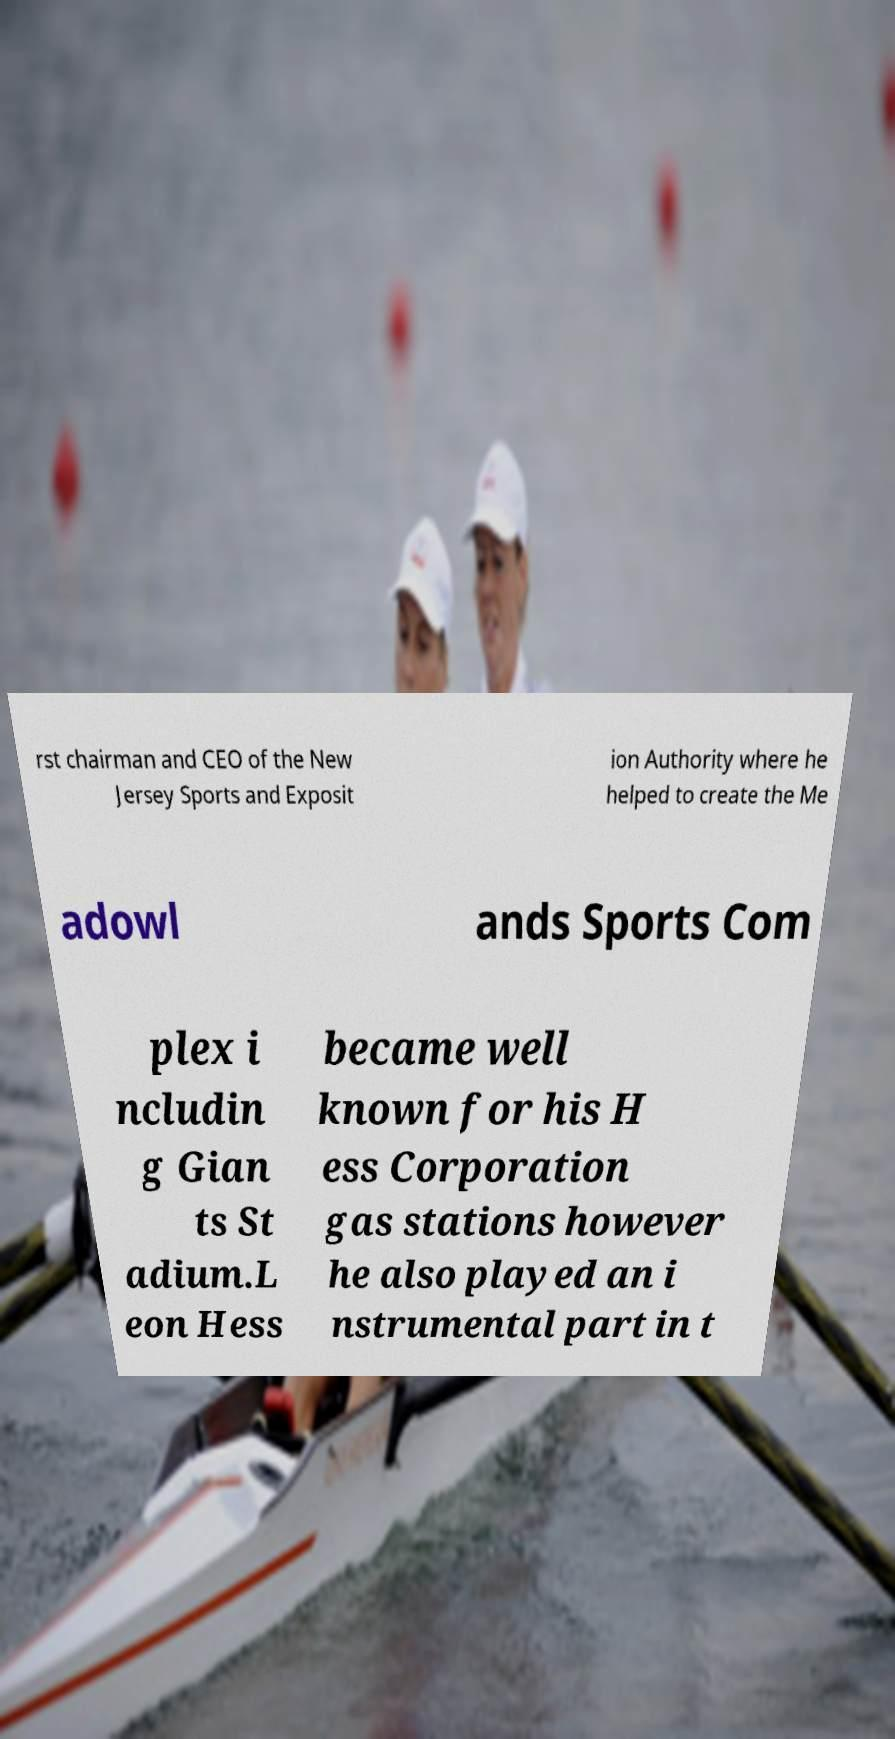Please identify and transcribe the text found in this image. rst chairman and CEO of the New Jersey Sports and Exposit ion Authority where he helped to create the Me adowl ands Sports Com plex i ncludin g Gian ts St adium.L eon Hess became well known for his H ess Corporation gas stations however he also played an i nstrumental part in t 